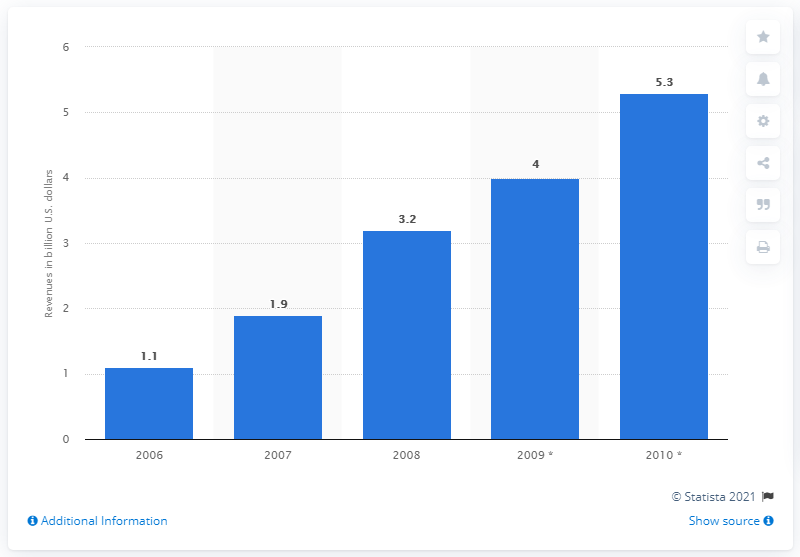Specify some key components in this picture. In 2007, the global revenue of organic textiles was 1.9 billion dollars. 